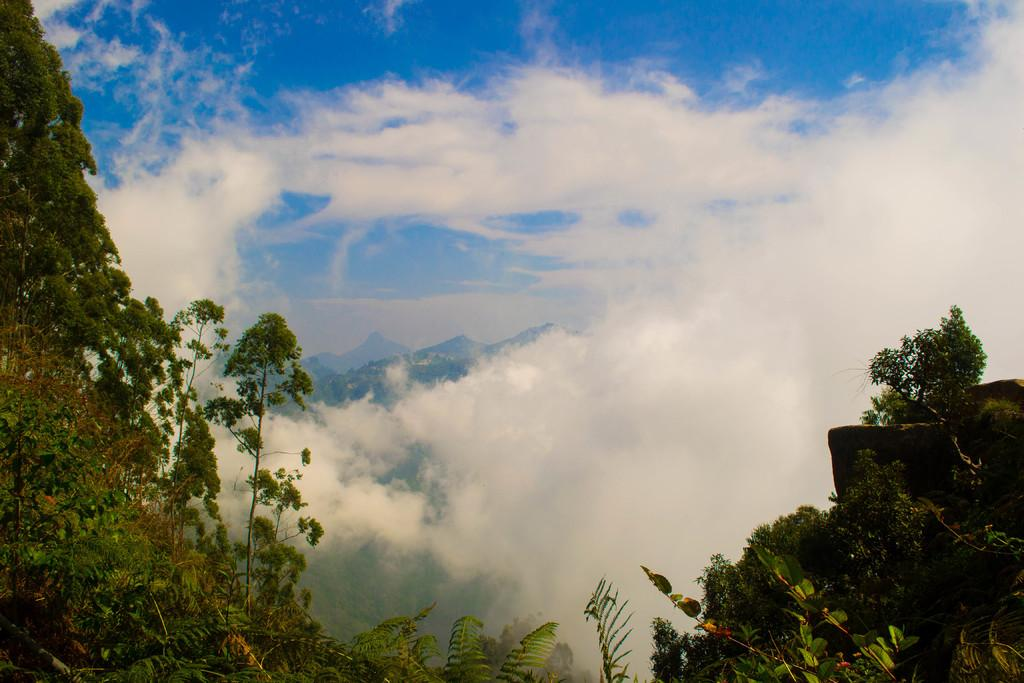What can be seen in the sky in the image? There are clouds in the sky in the image. What type of vegetation is present at the bottom of the image? Trees and plants are present at the bottom of the image. What geographical feature is located in the middle of the image? There are mountains in the middle of the image. Where is the street located in the image? There is no street present in the image; it features clouds, trees, plants, and mountains. Can you see any fairies flying around the trees in the image? There are no fairies present in the image; it only features natural elements such as clouds, trees, plants, and mountains. 